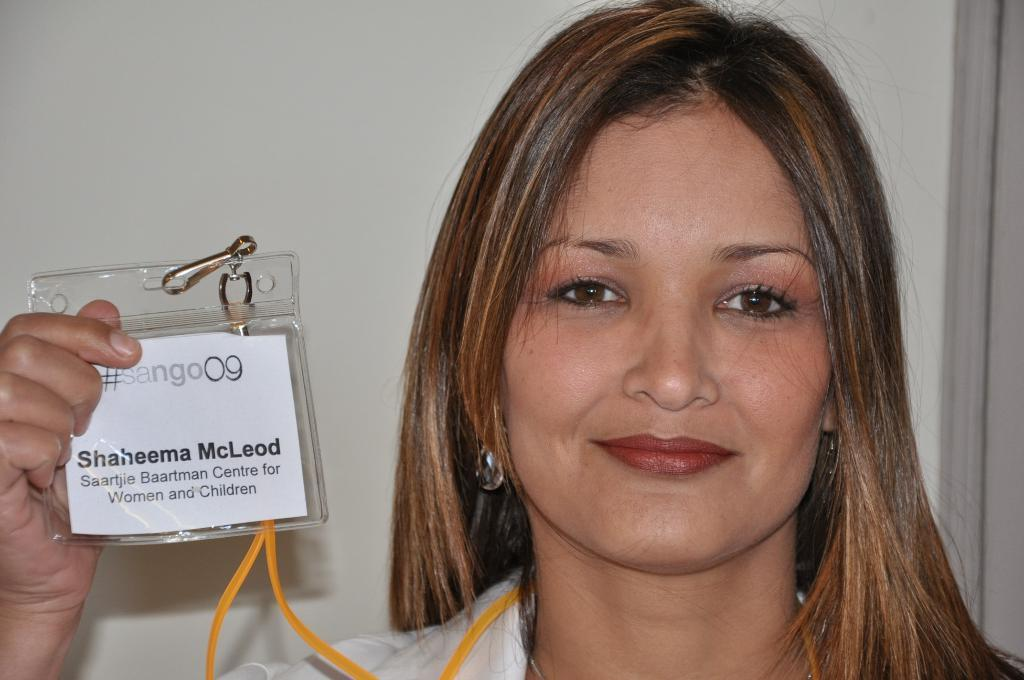Who is the main subject in the foreground of the image? There is a lady in the foreground of the image. What is the lady holding in the image? The lady is holding an ID card. What can be seen in the background of the image? There is a wall in the background of the image. What type of skirt is the lady wearing in the image? There is no information about the lady's skirt in the image, so we cannot determine what type of skirt she is wearing. 